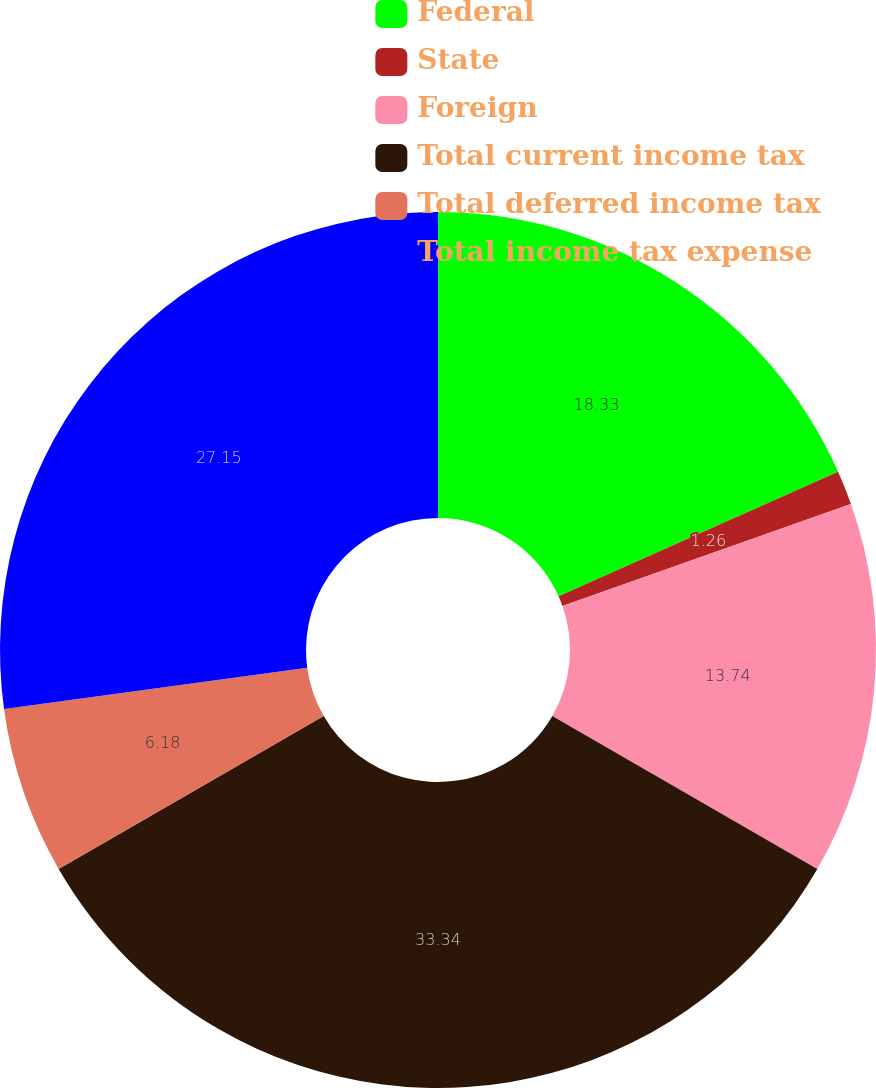Convert chart. <chart><loc_0><loc_0><loc_500><loc_500><pie_chart><fcel>Federal<fcel>State<fcel>Foreign<fcel>Total current income tax<fcel>Total deferred income tax<fcel>Total income tax expense<nl><fcel>18.33%<fcel>1.26%<fcel>13.74%<fcel>33.33%<fcel>6.18%<fcel>27.15%<nl></chart> 